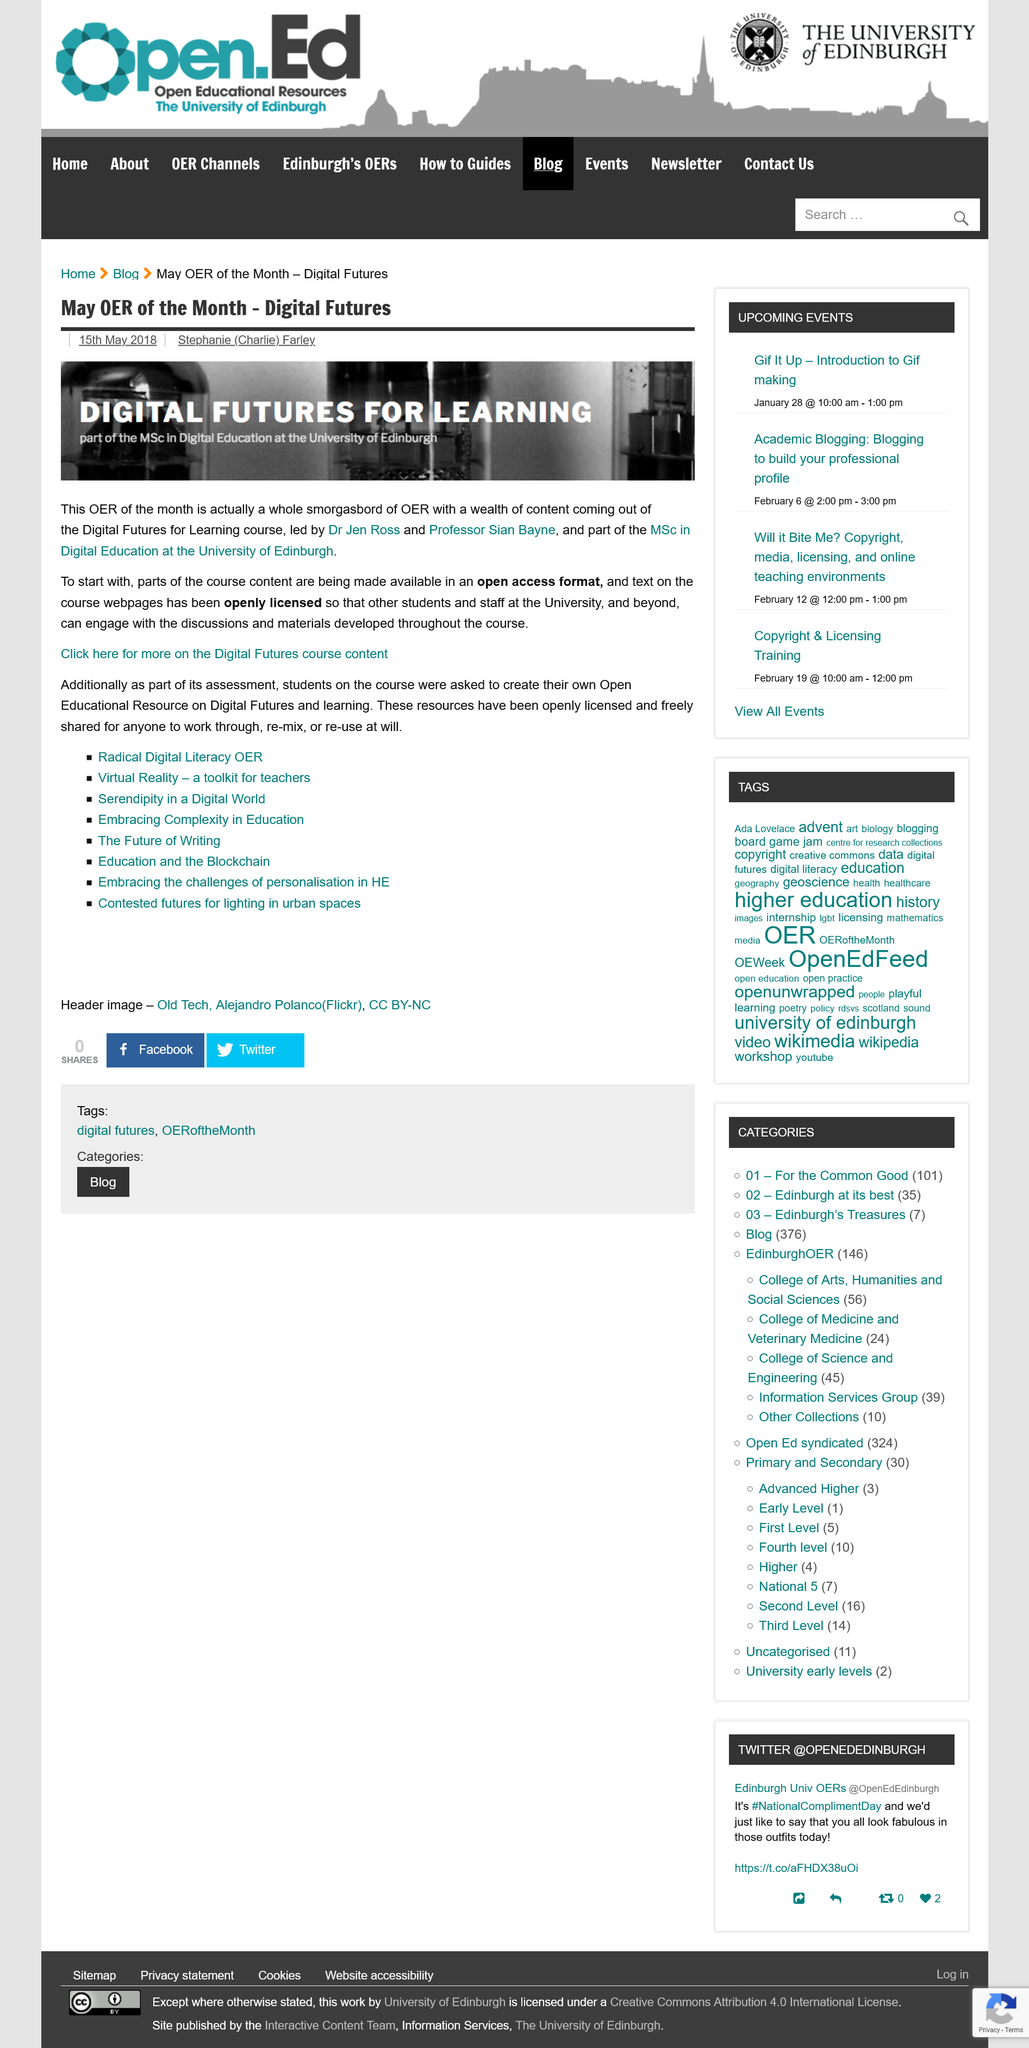Give some essential details in this illustration. In 2018, Dr. Jen Ross and Professor Sian Bayne led the Digital Futures for Learning course at Edinburgh. Students were tasked with creating their own open education resource on digital futures and learning as part of the assessment. The Digital Futures course website is licensed under an open license that allows for free use and access. 